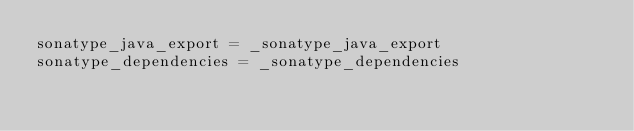Convert code to text. <code><loc_0><loc_0><loc_500><loc_500><_Python_>sonatype_java_export = _sonatype_java_export
sonatype_dependencies = _sonatype_dependencies
</code> 